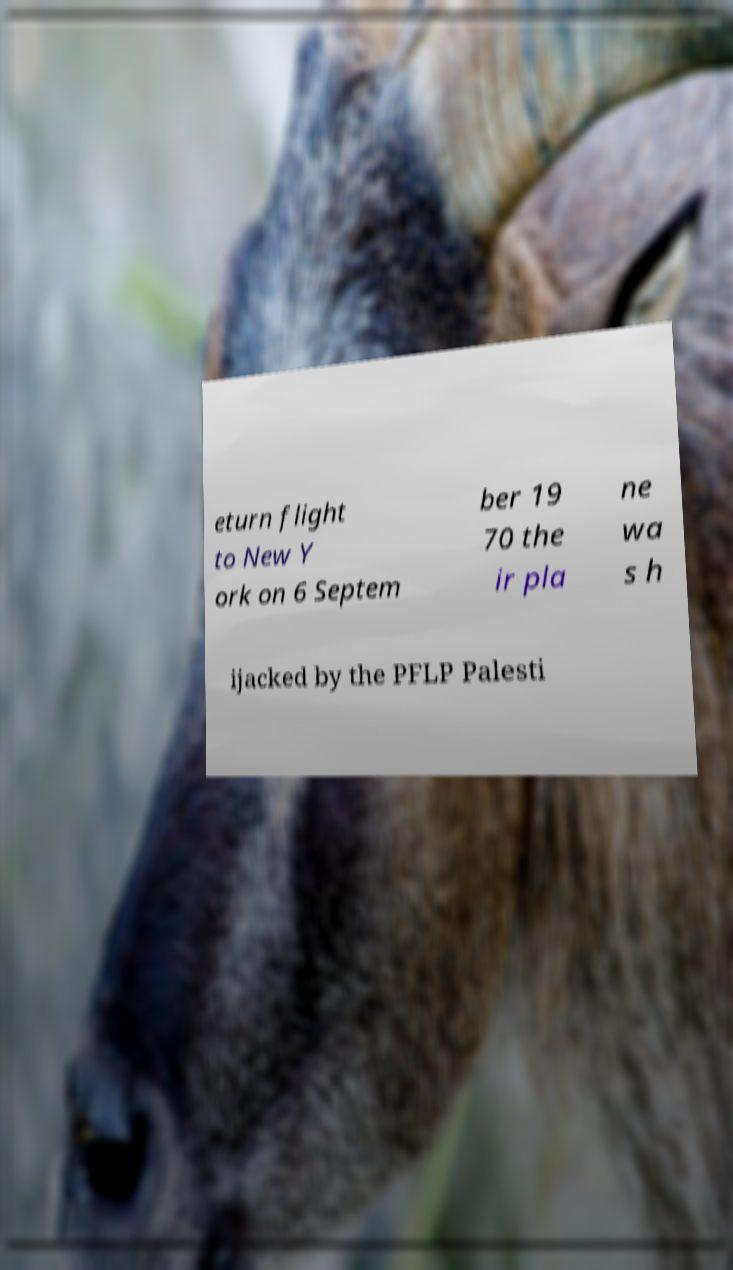I need the written content from this picture converted into text. Can you do that? eturn flight to New Y ork on 6 Septem ber 19 70 the ir pla ne wa s h ijacked by the PFLP Palesti 